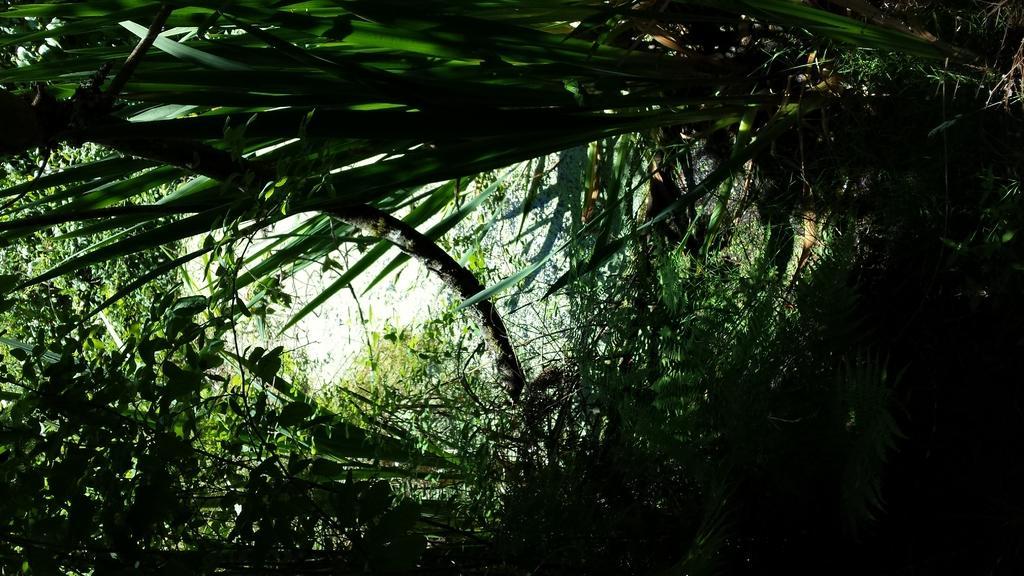Describe this image in one or two sentences. In the picture we can see some trees, leaves and top of the picture there is clear sky. 